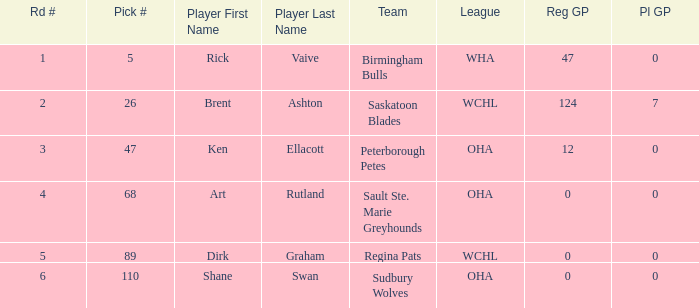How many reg GP for rick vaive in round 1? None. 